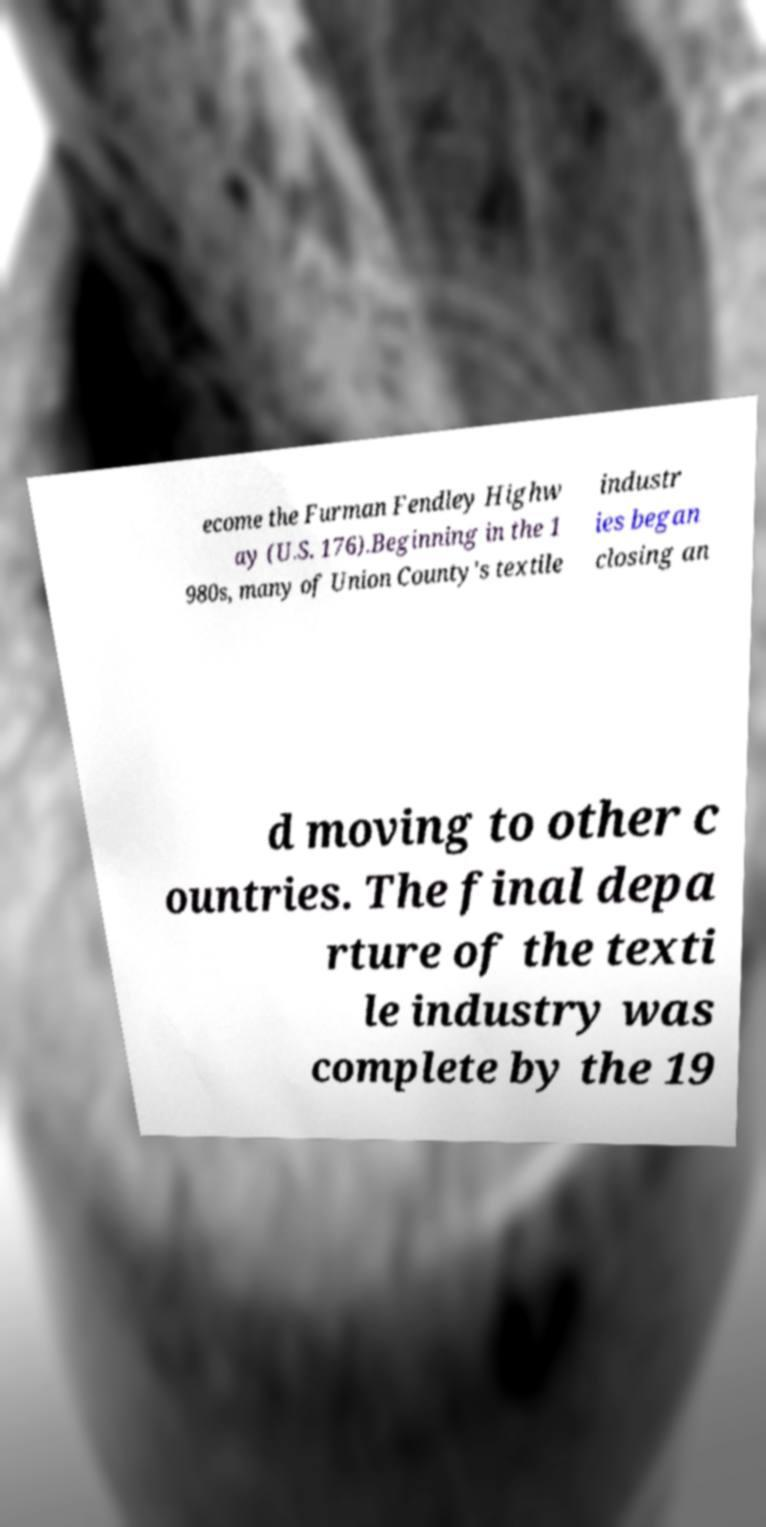Could you extract and type out the text from this image? ecome the Furman Fendley Highw ay (U.S. 176).Beginning in the 1 980s, many of Union County's textile industr ies began closing an d moving to other c ountries. The final depa rture of the texti le industry was complete by the 19 